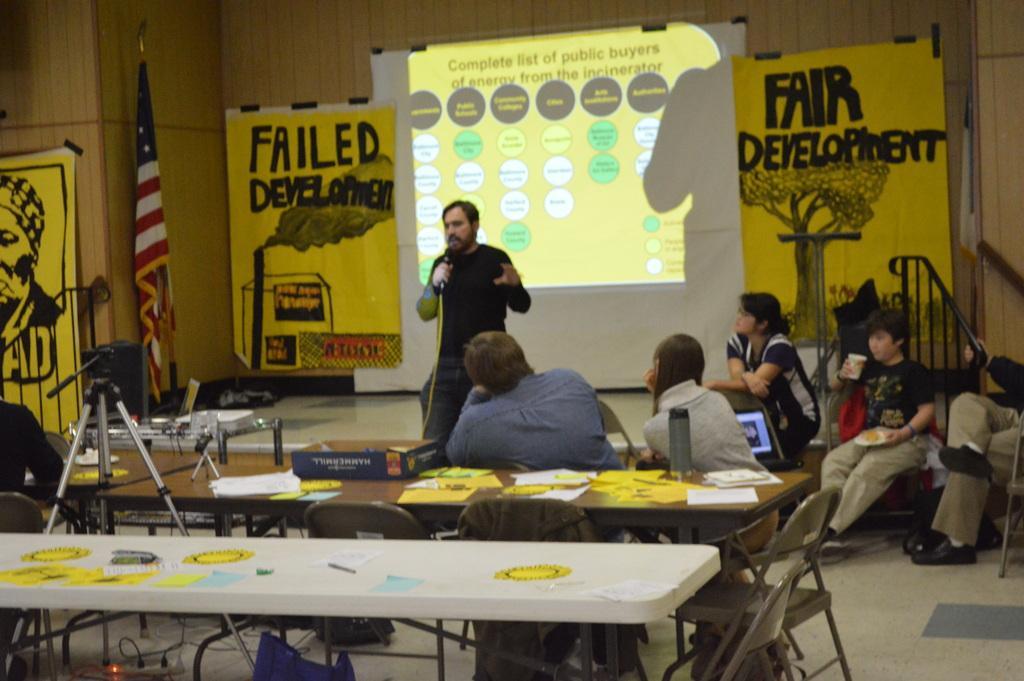In one or two sentences, can you explain what this image depicts? It looks like a workshop ,there are lot of yellow color banners in the image and also an american flag, a person who is standing is speaking something behind him there is a projector there are some tables and upon the tables there are some papers, the people sitting in the chair are paying attention to the man who is speaking ,in the background there is a wooden wall. 